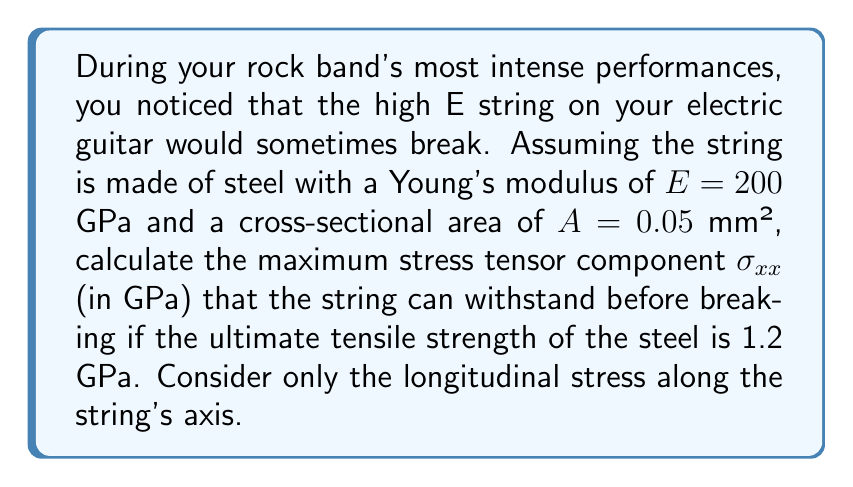Solve this math problem. To solve this problem, we'll use tensor mechanics and the concept of stress:

1) The stress tensor for a guitar string under tension can be simplified to a one-dimensional case, where only the longitudinal stress $\sigma_{xx}$ is significant. Other components are negligible.

2) The stress tensor in this case is:

   $$\sigma_{ij} = \begin{pmatrix}
   \sigma_{xx} & 0 & 0 \\
   0 & 0 & 0 \\
   0 & 0 & 0
   \end{pmatrix}$$

3) The ultimate tensile strength represents the maximum stress the material can withstand before breaking. In this case, it's given as 1.2 GPa.

4) Therefore, the maximum stress tensor component $\sigma_{xx}$ that the string can withstand is equal to the ultimate tensile strength:

   $$\sigma_{xx} = 1.2 \text{ GPa}$$

5) We can verify this using Hooke's law, which relates stress to strain:

   $$\sigma = E\varepsilon$$

   where $\sigma$ is stress, $E$ is Young's modulus, and $\varepsilon$ is strain.

6) The maximum strain before breaking would be:

   $$\varepsilon_{max} = \frac{\sigma_{xx}}{E} = \frac{1.2 \text{ GPa}}{200 \text{ GPa}} = 0.006 = 0.6\%$$

This strain of 0.6% is a reasonable value for the maximum elongation of steel before breaking, confirming our result.
Answer: $\sigma_{xx} = 1.2 \text{ GPa}$ 